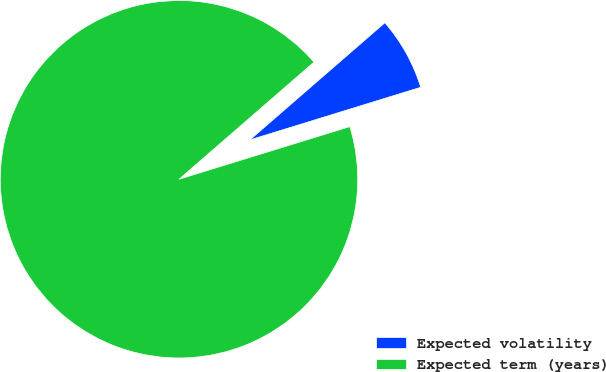Convert chart. <chart><loc_0><loc_0><loc_500><loc_500><pie_chart><fcel>Expected volatility<fcel>Expected term (years)<nl><fcel>6.62%<fcel>93.38%<nl></chart> 